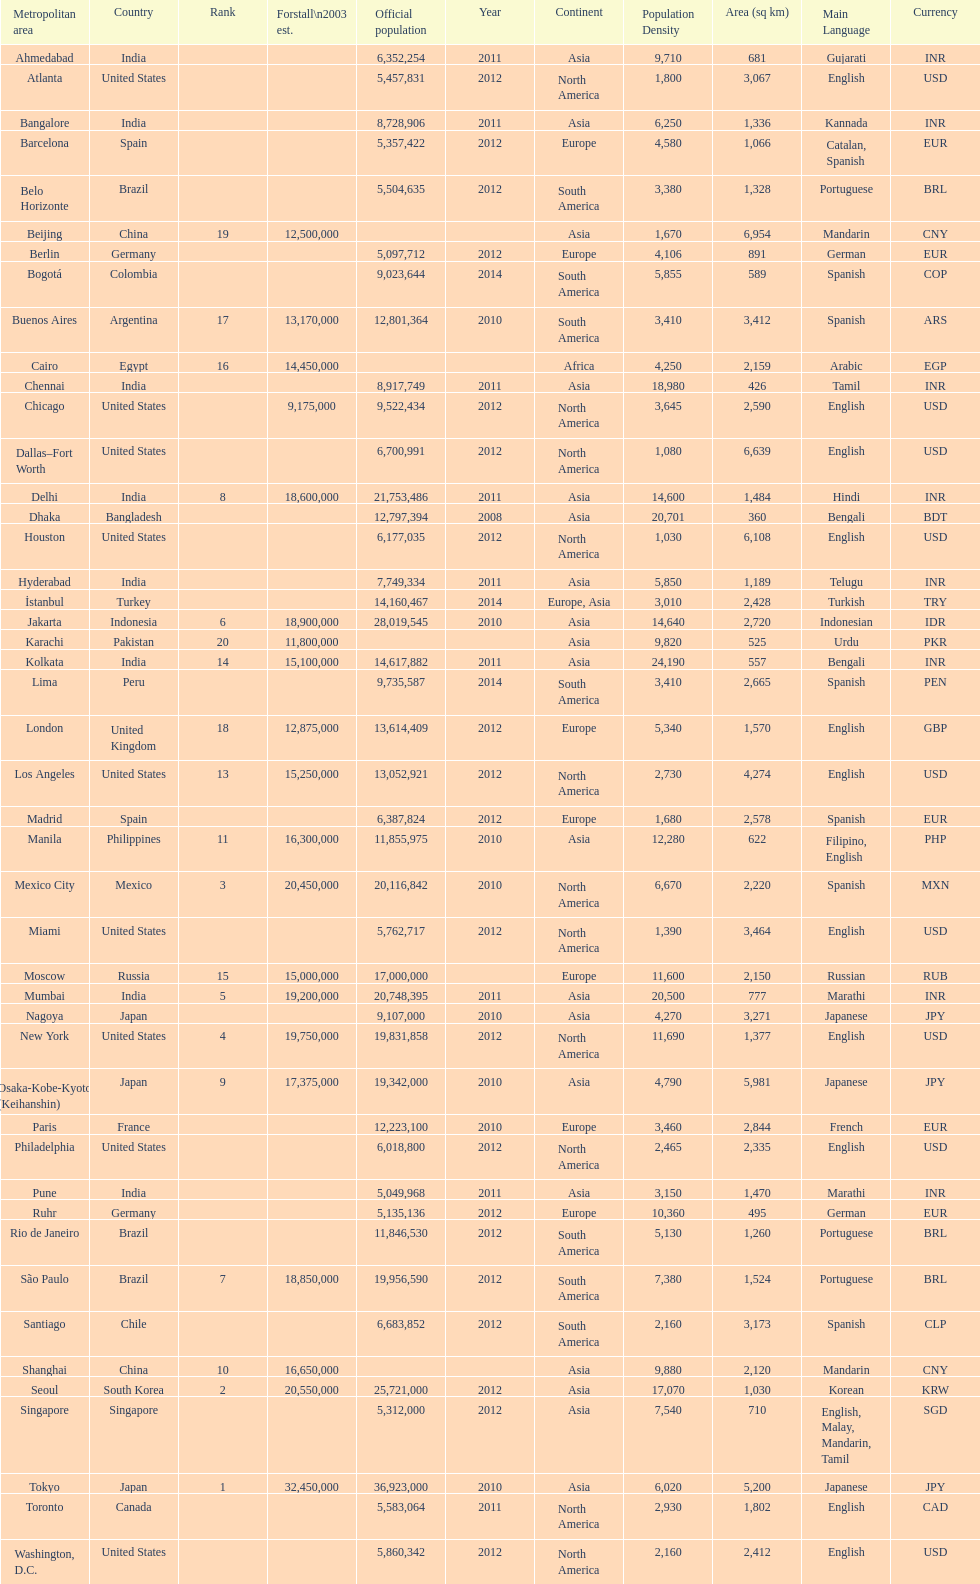How many cities are in the united states? 9. 